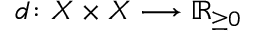<formula> <loc_0><loc_0><loc_500><loc_500>d \colon X \times X \longrightarrow \mathbb { R } _ { \geq 0 }</formula> 